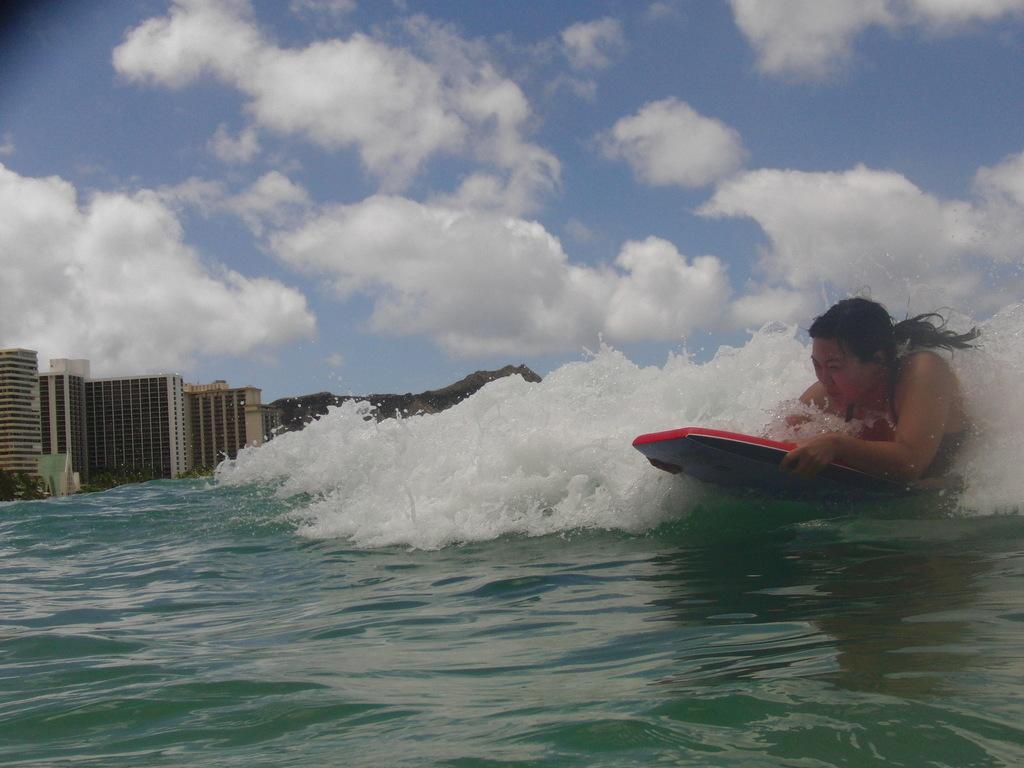In one or two sentences, can you explain what this image depicts? On the right middle a woman is skiing in the ocean who is half visible. At the bottom water is visible blue in color. In the left middle buildings are visible and mountain visible. On the top sky visible of blue in color. This image is taken during day time in the ocean. 